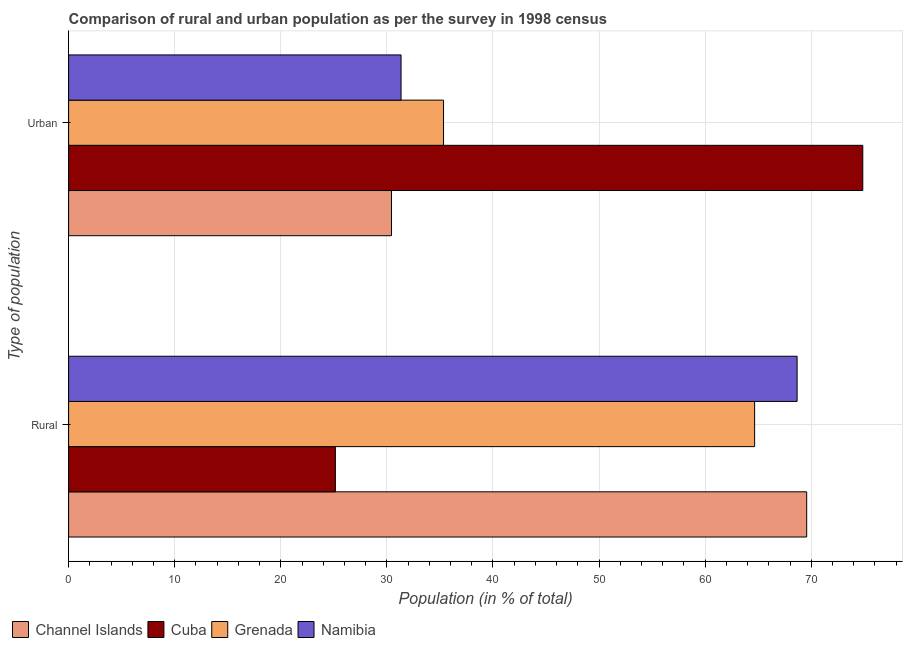How many different coloured bars are there?
Provide a short and direct response. 4. How many bars are there on the 2nd tick from the bottom?
Ensure brevity in your answer.  4. What is the label of the 1st group of bars from the top?
Offer a very short reply. Urban. What is the urban population in Grenada?
Provide a short and direct response. 35.34. Across all countries, what is the maximum rural population?
Your answer should be compact. 69.57. Across all countries, what is the minimum rural population?
Give a very brief answer. 25.14. In which country was the rural population maximum?
Your response must be concise. Channel Islands. In which country was the urban population minimum?
Make the answer very short. Channel Islands. What is the total rural population in the graph?
Give a very brief answer. 228.04. What is the difference between the rural population in Namibia and that in Channel Islands?
Your answer should be very brief. -0.9. What is the difference between the urban population in Namibia and the rural population in Grenada?
Ensure brevity in your answer.  -33.33. What is the average urban population per country?
Your answer should be compact. 42.99. What is the difference between the rural population and urban population in Namibia?
Your answer should be very brief. 37.33. In how many countries, is the urban population greater than 64 %?
Your answer should be compact. 1. What is the ratio of the rural population in Cuba to that in Channel Islands?
Give a very brief answer. 0.36. In how many countries, is the urban population greater than the average urban population taken over all countries?
Your answer should be compact. 1. What does the 1st bar from the top in Rural represents?
Offer a terse response. Namibia. What does the 3rd bar from the bottom in Rural represents?
Your response must be concise. Grenada. How many bars are there?
Your response must be concise. 8. Are all the bars in the graph horizontal?
Keep it short and to the point. Yes. What is the difference between two consecutive major ticks on the X-axis?
Your answer should be compact. 10. Are the values on the major ticks of X-axis written in scientific E-notation?
Your answer should be compact. No. Does the graph contain any zero values?
Give a very brief answer. No. How many legend labels are there?
Ensure brevity in your answer.  4. What is the title of the graph?
Your response must be concise. Comparison of rural and urban population as per the survey in 1998 census. Does "Ethiopia" appear as one of the legend labels in the graph?
Provide a short and direct response. No. What is the label or title of the X-axis?
Keep it short and to the point. Population (in % of total). What is the label or title of the Y-axis?
Make the answer very short. Type of population. What is the Population (in % of total) in Channel Islands in Rural?
Provide a succinct answer. 69.57. What is the Population (in % of total) in Cuba in Rural?
Ensure brevity in your answer.  25.14. What is the Population (in % of total) in Grenada in Rural?
Provide a short and direct response. 64.66. What is the Population (in % of total) of Namibia in Rural?
Offer a terse response. 68.67. What is the Population (in % of total) of Channel Islands in Urban?
Your response must be concise. 30.43. What is the Population (in % of total) of Cuba in Urban?
Your answer should be compact. 74.86. What is the Population (in % of total) of Grenada in Urban?
Your answer should be very brief. 35.34. What is the Population (in % of total) in Namibia in Urban?
Provide a short and direct response. 31.34. Across all Type of population, what is the maximum Population (in % of total) of Channel Islands?
Provide a succinct answer. 69.57. Across all Type of population, what is the maximum Population (in % of total) in Cuba?
Your response must be concise. 74.86. Across all Type of population, what is the maximum Population (in % of total) of Grenada?
Offer a very short reply. 64.66. Across all Type of population, what is the maximum Population (in % of total) of Namibia?
Make the answer very short. 68.67. Across all Type of population, what is the minimum Population (in % of total) in Channel Islands?
Ensure brevity in your answer.  30.43. Across all Type of population, what is the minimum Population (in % of total) of Cuba?
Offer a very short reply. 25.14. Across all Type of population, what is the minimum Population (in % of total) of Grenada?
Keep it short and to the point. 35.34. Across all Type of population, what is the minimum Population (in % of total) in Namibia?
Keep it short and to the point. 31.34. What is the total Population (in % of total) in Cuba in the graph?
Give a very brief answer. 100. What is the difference between the Population (in % of total) of Channel Islands in Rural and that in Urban?
Give a very brief answer. 39.14. What is the difference between the Population (in % of total) in Cuba in Rural and that in Urban?
Offer a very short reply. -49.71. What is the difference between the Population (in % of total) of Grenada in Rural and that in Urban?
Offer a very short reply. 29.32. What is the difference between the Population (in % of total) in Namibia in Rural and that in Urban?
Make the answer very short. 37.33. What is the difference between the Population (in % of total) of Channel Islands in Rural and the Population (in % of total) of Cuba in Urban?
Ensure brevity in your answer.  -5.29. What is the difference between the Population (in % of total) of Channel Islands in Rural and the Population (in % of total) of Grenada in Urban?
Provide a succinct answer. 34.23. What is the difference between the Population (in % of total) of Channel Islands in Rural and the Population (in % of total) of Namibia in Urban?
Your answer should be very brief. 38.23. What is the difference between the Population (in % of total) of Cuba in Rural and the Population (in % of total) of Grenada in Urban?
Your answer should be very brief. -10.19. What is the difference between the Population (in % of total) of Cuba in Rural and the Population (in % of total) of Namibia in Urban?
Make the answer very short. -6.19. What is the difference between the Population (in % of total) of Grenada in Rural and the Population (in % of total) of Namibia in Urban?
Make the answer very short. 33.33. What is the average Population (in % of total) in Grenada per Type of population?
Make the answer very short. 50. What is the average Population (in % of total) in Namibia per Type of population?
Give a very brief answer. 50. What is the difference between the Population (in % of total) of Channel Islands and Population (in % of total) of Cuba in Rural?
Your answer should be very brief. 44.42. What is the difference between the Population (in % of total) in Channel Islands and Population (in % of total) in Grenada in Rural?
Provide a succinct answer. 4.91. What is the difference between the Population (in % of total) of Channel Islands and Population (in % of total) of Namibia in Rural?
Your response must be concise. 0.9. What is the difference between the Population (in % of total) of Cuba and Population (in % of total) of Grenada in Rural?
Keep it short and to the point. -39.52. What is the difference between the Population (in % of total) of Cuba and Population (in % of total) of Namibia in Rural?
Your answer should be compact. -43.52. What is the difference between the Population (in % of total) of Grenada and Population (in % of total) of Namibia in Rural?
Your answer should be compact. -4. What is the difference between the Population (in % of total) of Channel Islands and Population (in % of total) of Cuba in Urban?
Ensure brevity in your answer.  -44.42. What is the difference between the Population (in % of total) in Channel Islands and Population (in % of total) in Grenada in Urban?
Ensure brevity in your answer.  -4.91. What is the difference between the Population (in % of total) in Channel Islands and Population (in % of total) in Namibia in Urban?
Keep it short and to the point. -0.9. What is the difference between the Population (in % of total) in Cuba and Population (in % of total) in Grenada in Urban?
Provide a succinct answer. 39.52. What is the difference between the Population (in % of total) in Cuba and Population (in % of total) in Namibia in Urban?
Your answer should be compact. 43.52. What is the difference between the Population (in % of total) in Grenada and Population (in % of total) in Namibia in Urban?
Provide a succinct answer. 4. What is the ratio of the Population (in % of total) of Channel Islands in Rural to that in Urban?
Keep it short and to the point. 2.29. What is the ratio of the Population (in % of total) in Cuba in Rural to that in Urban?
Your response must be concise. 0.34. What is the ratio of the Population (in % of total) of Grenada in Rural to that in Urban?
Provide a short and direct response. 1.83. What is the ratio of the Population (in % of total) in Namibia in Rural to that in Urban?
Provide a short and direct response. 2.19. What is the difference between the highest and the second highest Population (in % of total) in Channel Islands?
Give a very brief answer. 39.14. What is the difference between the highest and the second highest Population (in % of total) in Cuba?
Your answer should be very brief. 49.71. What is the difference between the highest and the second highest Population (in % of total) of Grenada?
Keep it short and to the point. 29.32. What is the difference between the highest and the second highest Population (in % of total) of Namibia?
Provide a short and direct response. 37.33. What is the difference between the highest and the lowest Population (in % of total) in Channel Islands?
Offer a terse response. 39.14. What is the difference between the highest and the lowest Population (in % of total) of Cuba?
Keep it short and to the point. 49.71. What is the difference between the highest and the lowest Population (in % of total) of Grenada?
Ensure brevity in your answer.  29.32. What is the difference between the highest and the lowest Population (in % of total) in Namibia?
Provide a succinct answer. 37.33. 